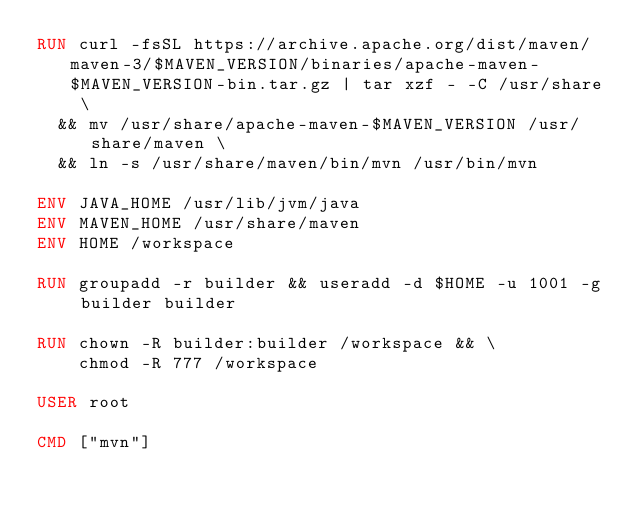<code> <loc_0><loc_0><loc_500><loc_500><_Dockerfile_>RUN curl -fsSL https://archive.apache.org/dist/maven/maven-3/$MAVEN_VERSION/binaries/apache-maven-$MAVEN_VERSION-bin.tar.gz | tar xzf - -C /usr/share \
  && mv /usr/share/apache-maven-$MAVEN_VERSION /usr/share/maven \
  && ln -s /usr/share/maven/bin/mvn /usr/bin/mvn

ENV JAVA_HOME /usr/lib/jvm/java
ENV MAVEN_HOME /usr/share/maven
ENV HOME /workspace

RUN groupadd -r builder && useradd -d $HOME -u 1001 -g builder builder

RUN chown -R builder:builder /workspace && \
    chmod -R 777 /workspace

USER root

CMD ["mvn"]</code> 